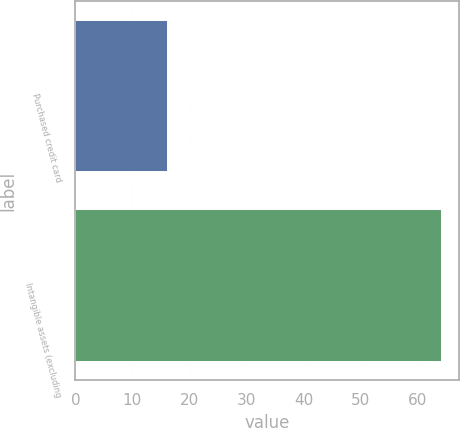Convert chart. <chart><loc_0><loc_0><loc_500><loc_500><bar_chart><fcel>Purchased credit card<fcel>Intangible assets (excluding<nl><fcel>16<fcel>64<nl></chart> 